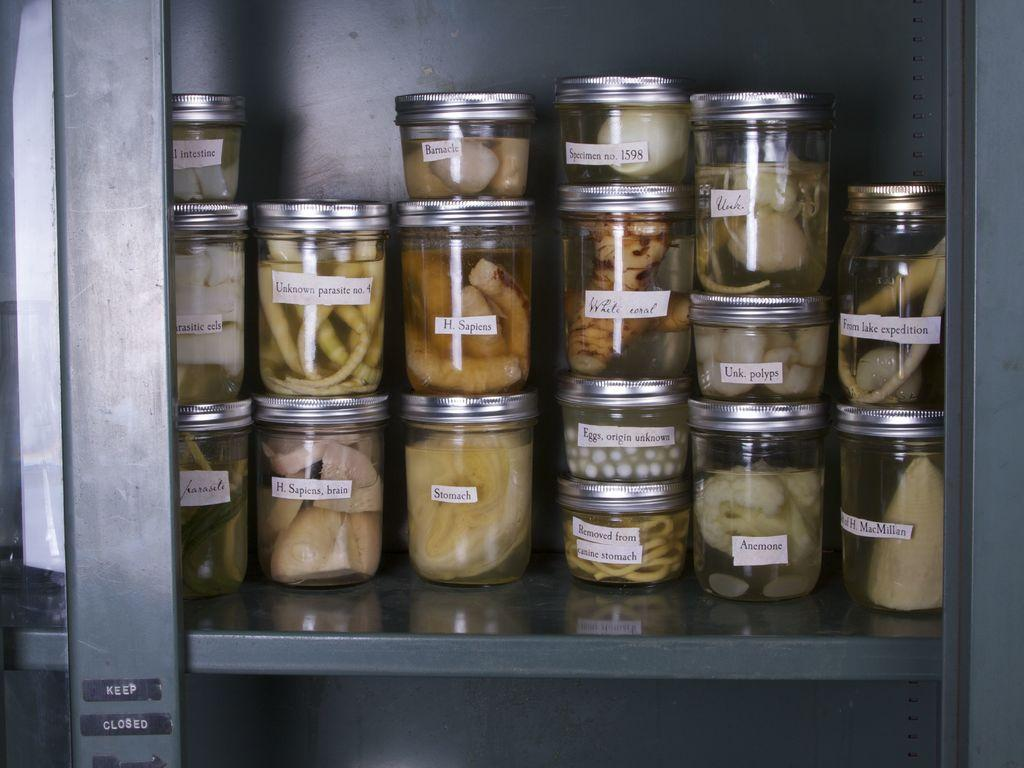What can be seen on the rack in the image? There are jar bottles with items in them on a rack. What is located on the left side of the image? There is an object on the left side of the image. What vertical structure can be seen in the image? There is a pole in the image. What type of jelly is visible in the stomach of the beast in the image? There is no jelly or beast present in the image. How does the pole interact with the beast in the image? There is no beast present in the image, so the pole does not interact with any beast. 